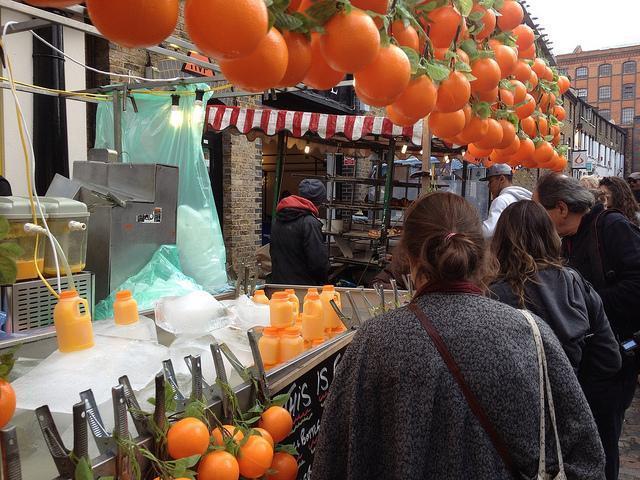How many oranges can you see?
Give a very brief answer. 6. How many people are in the picture?
Give a very brief answer. 4. How many handbags are in the photo?
Give a very brief answer. 2. How many kites do you see?
Give a very brief answer. 0. 